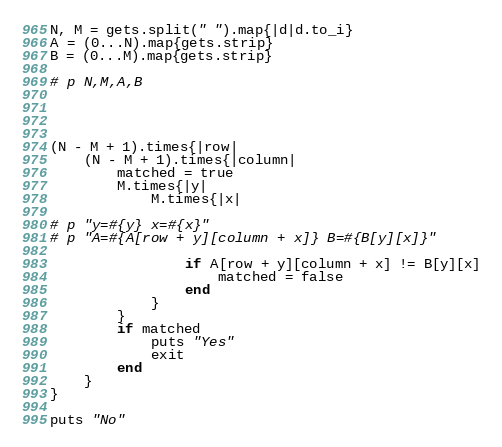<code> <loc_0><loc_0><loc_500><loc_500><_Ruby_>N, M = gets.split(" ").map{|d|d.to_i}
A = (0...N).map{gets.strip}
B = (0...M).map{gets.strip}

# p N,M,A,B




(N - M + 1).times{|row|
	(N - M + 1).times{|column|
		matched = true
		M.times{|y|
			M.times{|x|

# p "y=#{y} x=#{x}"
# p "A=#{A[row + y][column + x]} B=#{B[y][x]}"

				if A[row + y][column + x] != B[y][x]
					matched = false
				end
			}
		}
		if matched
			puts "Yes"
			exit
		end
	}
}

puts "No"
</code> 